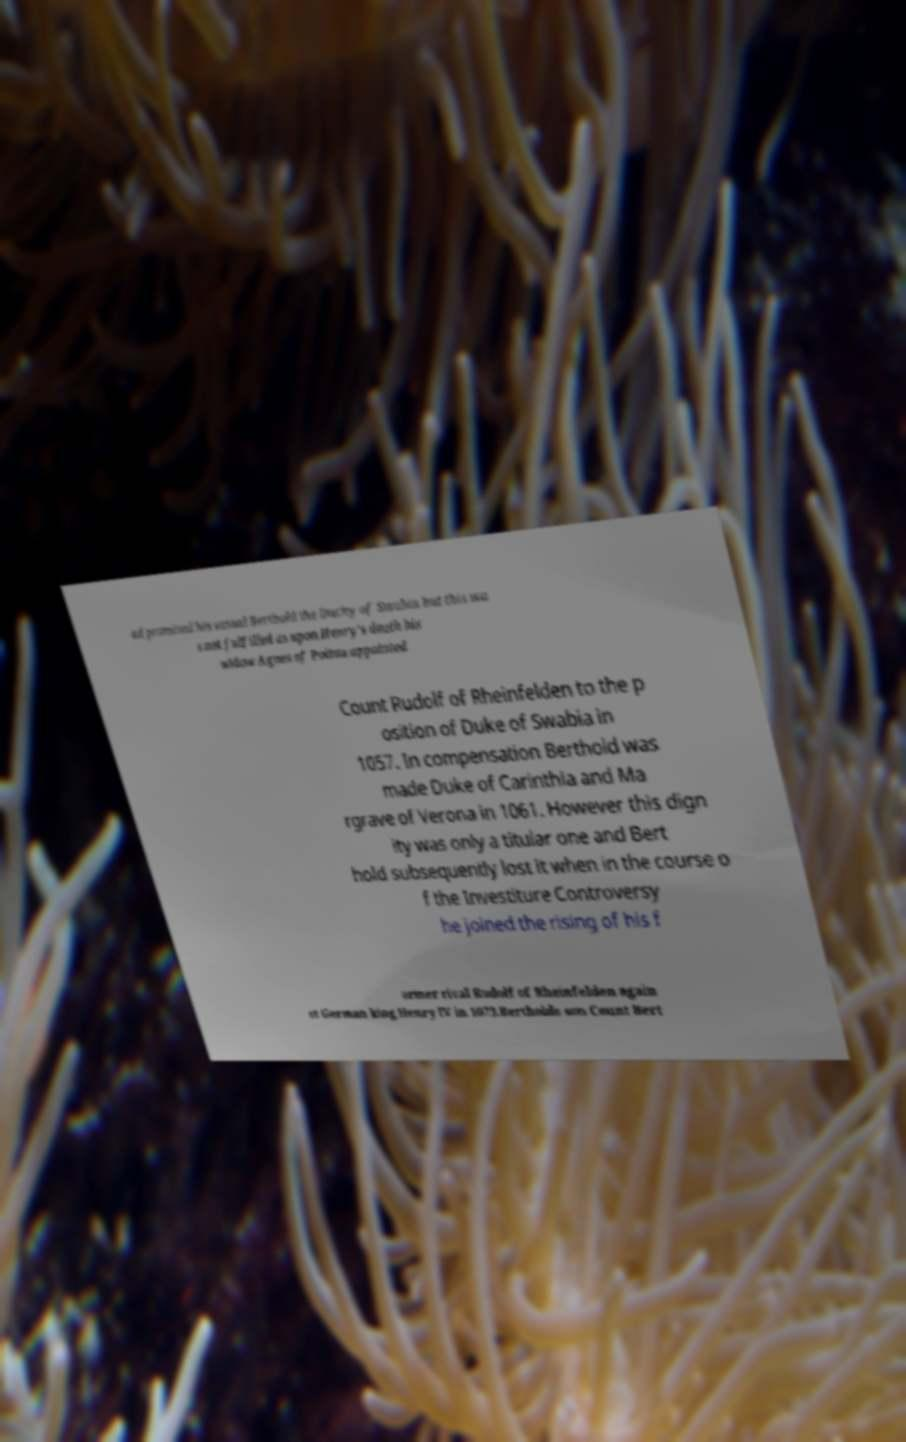What messages or text are displayed in this image? I need them in a readable, typed format. ad promised his vassal Berthold the Duchy of Swabia but this wa s not fulfilled as upon Henry's death his widow Agnes of Poitou appointed Count Rudolf of Rheinfelden to the p osition of Duke of Swabia in 1057. In compensation Berthold was made Duke of Carinthia and Ma rgrave of Verona in 1061. However this dign ity was only a titular one and Bert hold subsequently lost it when in the course o f the Investiture Controversy he joined the rising of his f ormer rival Rudolf of Rheinfelden again st German king Henry IV in 1073.Bertholds son Count Bert 